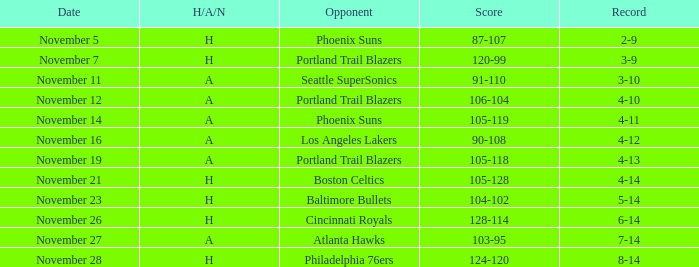On what Date was the Score 105-118 and the H/A/N A? November 19. I'm looking to parse the entire table for insights. Could you assist me with that? {'header': ['Date', 'H/A/N', 'Opponent', 'Score', 'Record'], 'rows': [['November 5', 'H', 'Phoenix Suns', '87-107', '2-9'], ['November 7', 'H', 'Portland Trail Blazers', '120-99', '3-9'], ['November 11', 'A', 'Seattle SuperSonics', '91-110', '3-10'], ['November 12', 'A', 'Portland Trail Blazers', '106-104', '4-10'], ['November 14', 'A', 'Phoenix Suns', '105-119', '4-11'], ['November 16', 'A', 'Los Angeles Lakers', '90-108', '4-12'], ['November 19', 'A', 'Portland Trail Blazers', '105-118', '4-13'], ['November 21', 'H', 'Boston Celtics', '105-128', '4-14'], ['November 23', 'H', 'Baltimore Bullets', '104-102', '5-14'], ['November 26', 'H', 'Cincinnati Royals', '128-114', '6-14'], ['November 27', 'A', 'Atlanta Hawks', '103-95', '7-14'], ['November 28', 'H', 'Philadelphia 76ers', '124-120', '8-14']]} 